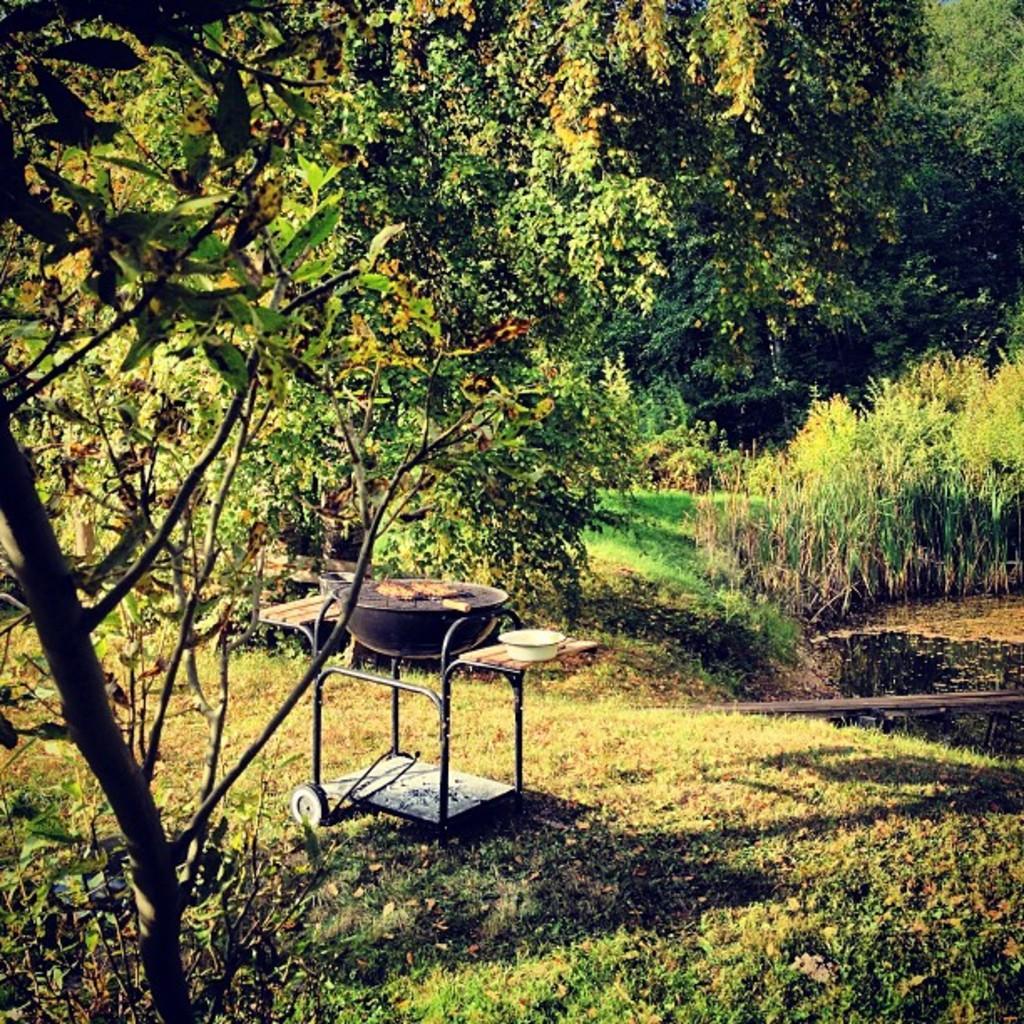How would you summarize this image in a sentence or two? In this image we can see trees, water and a barbecue on the trolley. 